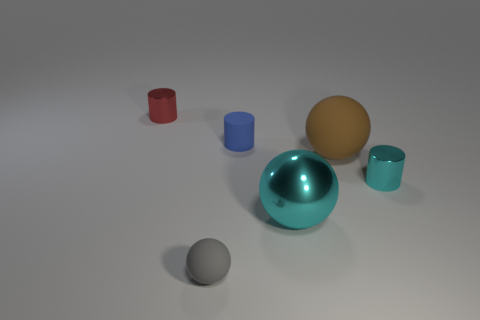Can you describe the lighting in the scene and how it affects the mood of the image? The lighting in the scene is soft and diffuse, creating gentle shadows and maintaining a calm and neutral mood. The light highlights the objects' textures and the reflective quality of the metallic surfaces. 